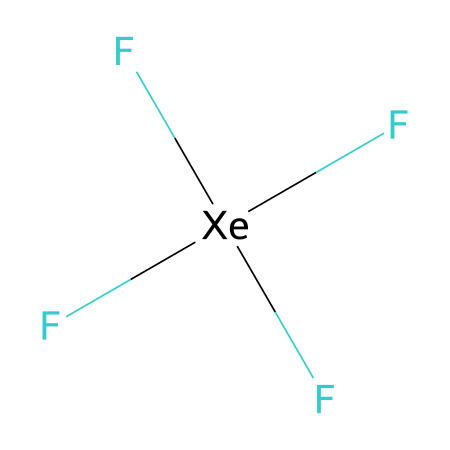how many fluorine atoms are present in xenon tetrafluoride? The SMILES representation shows four 'F' characters explicitly, indicating that there are four fluorine atoms directly bonded to the xenon atom.
Answer: four what type of bonding is present in xenon tetrafluoride? The presence of multiple fluorine atoms bonded to the xenon atom suggests that there are covalent bonds, specifically coordinate covalent bonds due to the formation of a hypervalent compound.
Answer: covalent how many valence electrons does xenon have in this compound? Xenon has 8 valence electrons in total, as a noble gas, but it expands its valence shell due to bonding with the four fluorine atoms, which allows it to accommodate more electrons in this hypervalent structure.
Answer: eight is xenon tetrafluoride considered a hypervalent compound? Yes, xenon tetrafluoride is hypervalent because xenon has more than four pairs of electrons in its valence shell due to the bonding with four fluorine atoms.
Answer: yes what is the geometric shape of xenon tetrafluoride? The chemical structure typically leads to a square planar arrangement due to the four fluorine atoms surrounding the xenon atom and the specific angles of bonding.
Answer: square planar what is the overall charge of xenon tetrafluoride? There are no free electrons or charges indicated in the structure, and since all atoms are neutral, it results in a neutral overall charge for xenon tetrafluoride.
Answer: neutral 